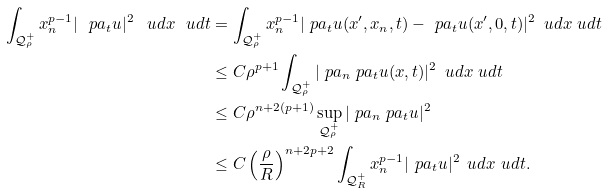Convert formula to latex. <formula><loc_0><loc_0><loc_500><loc_500>\int _ { \mathcal { Q } _ { \rho } ^ { + } } x _ { n } ^ { p - 1 } | \ p a _ { t } u | ^ { 2 } \, \ u d x \ u d t & = \int _ { \mathcal { Q } _ { \rho } ^ { + } } x _ { n } ^ { p - 1 } | \ p a _ { t } u ( x ^ { \prime } , x _ { n } , t ) - \ p a _ { t } u ( x ^ { \prime } , 0 , t ) | ^ { 2 } \, \ u d x \ u d t \\ & \leq C \rho ^ { p + 1 } \int _ { \mathcal { Q } _ { \rho } ^ { + } } | \ p a _ { n } \ p a _ { t } u ( x , t ) | ^ { 2 } \, \ u d x \ u d t \\ & \leq C \rho ^ { n + 2 ( p + 1 ) } \sup _ { \mathcal { Q } _ { \rho } ^ { + } } | \ p a _ { n } \ p a _ { t } u | ^ { 2 } \\ & \leq C \left ( \frac { \rho } { R } \right ) ^ { n + 2 p + 2 } \int _ { \mathcal { Q } _ { R } ^ { + } } x _ { n } ^ { p - 1 } | \ p a _ { t } u | ^ { 2 } \, \ u d x \ u d t .</formula> 